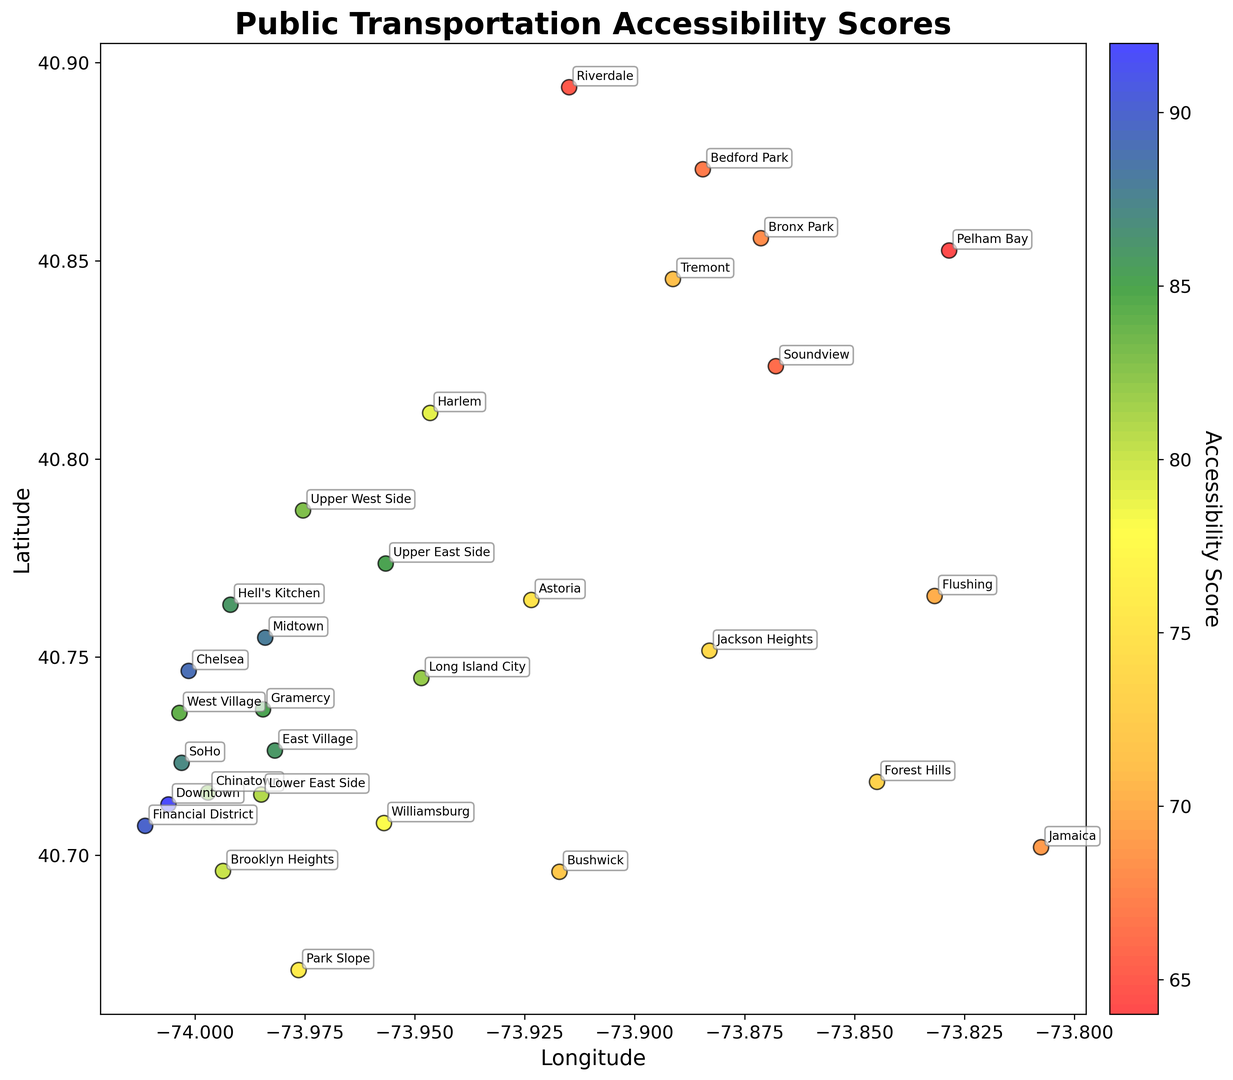Which neighborhood has the highest public transportation accessibility score? Look at the scatter plot and find the data point with the highest score on the color spectrum. Check the annotated label for that point.
Answer: Downtown Which neighborhood has the lowest public transportation accessibility score? Look at the scatter plot for the data point with the color indicating the lowest score and check the annotated label.
Answer: Riverdale What is the average public transportation accessibility score for neighborhoods in the Bronx? Identify the Bronx neighborhoods from the annotations (Harlem, Bronx Park, Riverdale, Pelham Bay, Bedford Park, Tremont, Soundview), sum their accessibility scores (79 + 68 + 65 + 64 + 67 + 71 + 66 = 480) and divide by the number of neighborhoods (7).
Answer: 68.57 How does the public transportation accessibility score of Chelsea compare to that of Williamsburg? Find the positions for Chelsea and Williamsburg in the plot and compare their color intensities indicating the accessibility score.
Answer: Chelsea has a higher score than Williamsburg Which neighborhood between Astoria and Jamaica has a better public transportation accessibility score? Locate Astoria and Jamaica on the plot by their geographic coordinates and compare their scores using the color indicated.
Answer: Astoria Is there a significant difference in public transportation accessibility scores between neighborhoods in Manhattan and Brooklyn? Identify the neighborhoods in Manhattan, sum their scores, and compute the average. Repeat the same for Brooklyn neighborhoods. Compare the averages. Manhattan neighborhoods have generally higher scores.
Answer: Yes, significant difference with Manhattan higher What neighborhood closest in score to Chinatown is located in Manhattan? Locate Chinatown on the plot, identify its accessibility score, then look for the nearest matching score among other Manhattan neighborhoods.
Answer: Lower East Side What is the range of public transportation accessibility scores for neighborhoods in Queens? Identify neighborhoods in Queens (Long Island City, Jackson Heights, Flushing, Forest Hills, Astoria, Jamaica), then find the highest (82) and lowest scores (69) among them. Subtract the lowest from the highest score.
Answer: 13 Do neighborhoods with higher latitude coordinates generally have higher public transportation accessibility scores? Visually inspect the relationship between latitude coordinates and colors (scores). Higher latitude does not consistently correspond to higher scores.
Answer: No How much higher is the score of Hell's Kitchen compared to Astoria? Find Hell's Kitchen and Astoria on the plot, note their scores (86 for Hell's Kitchen, 75 for Astoria), and calculate the difference (86 - 75).
Answer: 11 